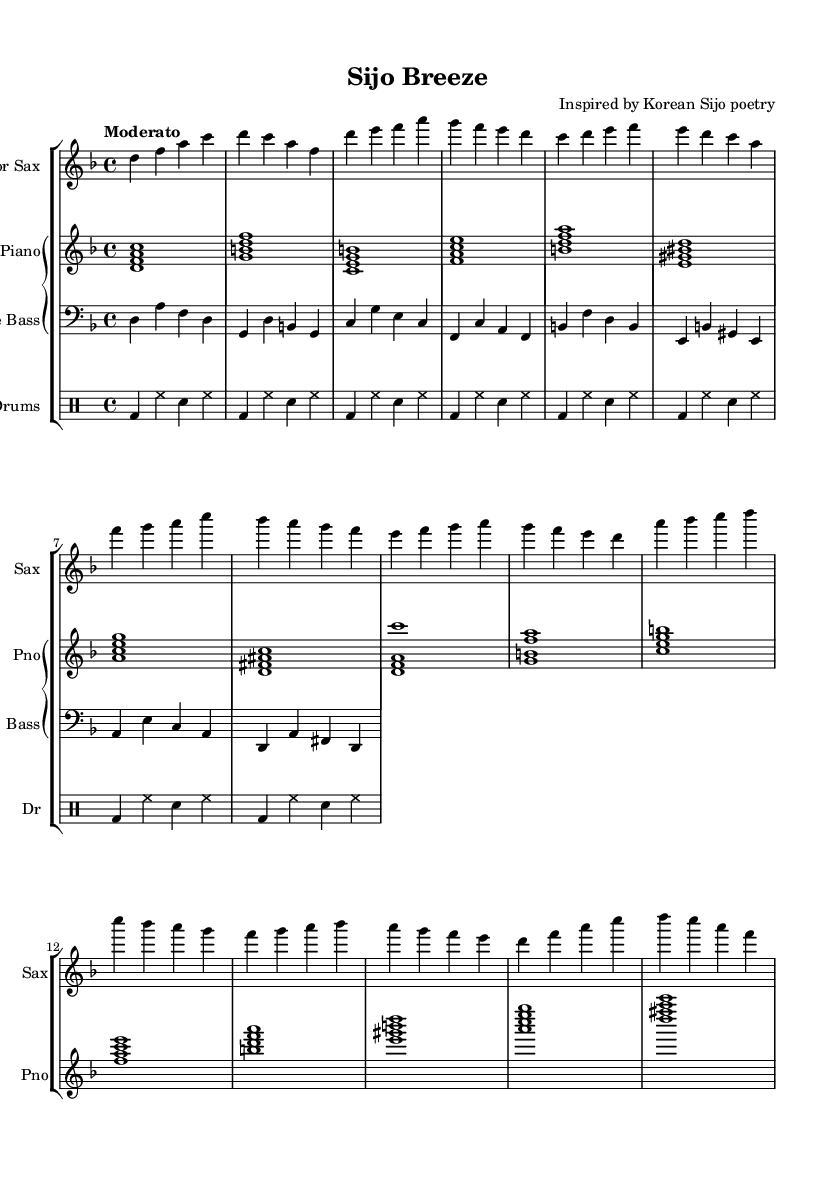What is the key signature of this music? The key signature is D minor, which has one flat (B flat). This can be identified by looking at the beginning of the staff, where the key signature is indicated.
Answer: D minor What is the time signature of this piece? The time signature is 4/4, shown at the beginning near the clefs. It indicates that there are four beats in each measure and the quarter note gets one beat.
Answer: 4/4 What is the tempo marking for the composition? The tempo marking is "Moderato," which suggests a moderate speed, typically around 108 to 120 beats per minute. This is directly stated above the staff in the tempo indication.
Answer: Moderato Which instrument is playing the main melody in this arrangement? The saxophone is the instrument indicated as playing the main melody, as the saxophone part is listed first and contains the primary musical material of the piece.
Answer: Saxophone How many sections are there in this piece? There are three distinct sections labeled A, B, and C, followed by an Outro section that uses material from the Intro. Each section has unique melodic content, as indicated within the music.
Answer: Four What type of chords are primarily used in the piano part? The piano part primarily features jazz chords, including minor 7th and major 7th chords, which are commonly found in jazz music due to their rich harmonic quality. This can be observed in the chord symbols placed above the staff.
Answer: Jazz chords What style of drumming is employed in this arrangement? The drumming style employed is a basic swing pattern, which is typical in jazz music. This is discerned from the rhythm notation and the use of swing eighth notes in the drum part, creating an energetic feel typical of jazz.
Answer: Swing pattern 